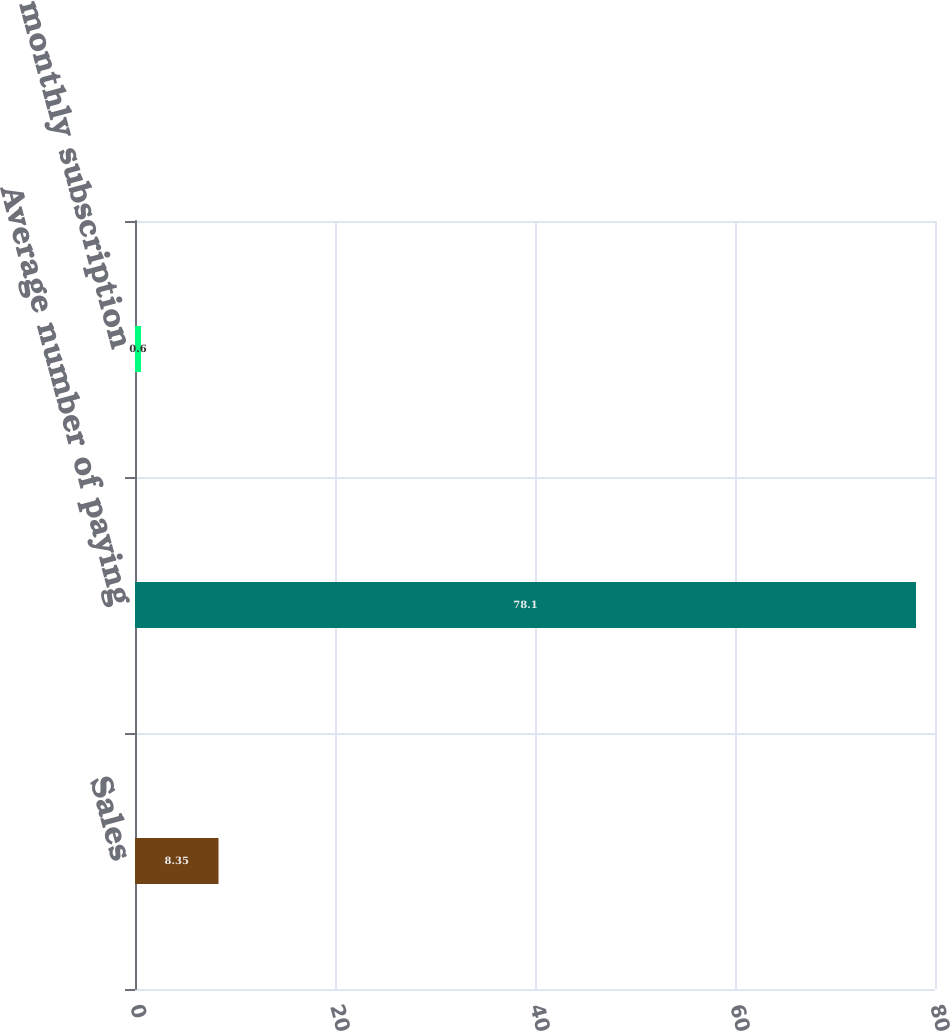<chart> <loc_0><loc_0><loc_500><loc_500><bar_chart><fcel>Sales<fcel>Average number of paying<fcel>Average monthly subscription<nl><fcel>8.35<fcel>78.1<fcel>0.6<nl></chart> 